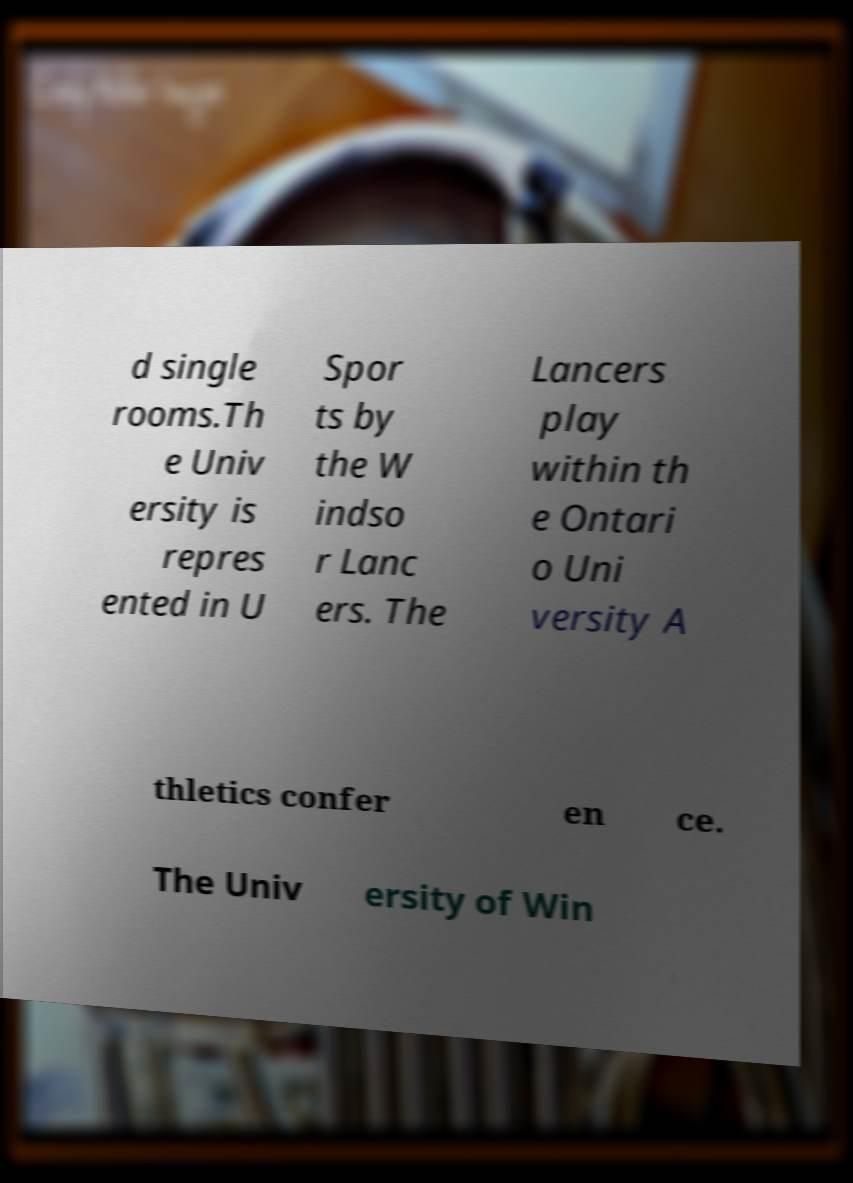Could you extract and type out the text from this image? d single rooms.Th e Univ ersity is repres ented in U Spor ts by the W indso r Lanc ers. The Lancers play within th e Ontari o Uni versity A thletics confer en ce. The Univ ersity of Win 